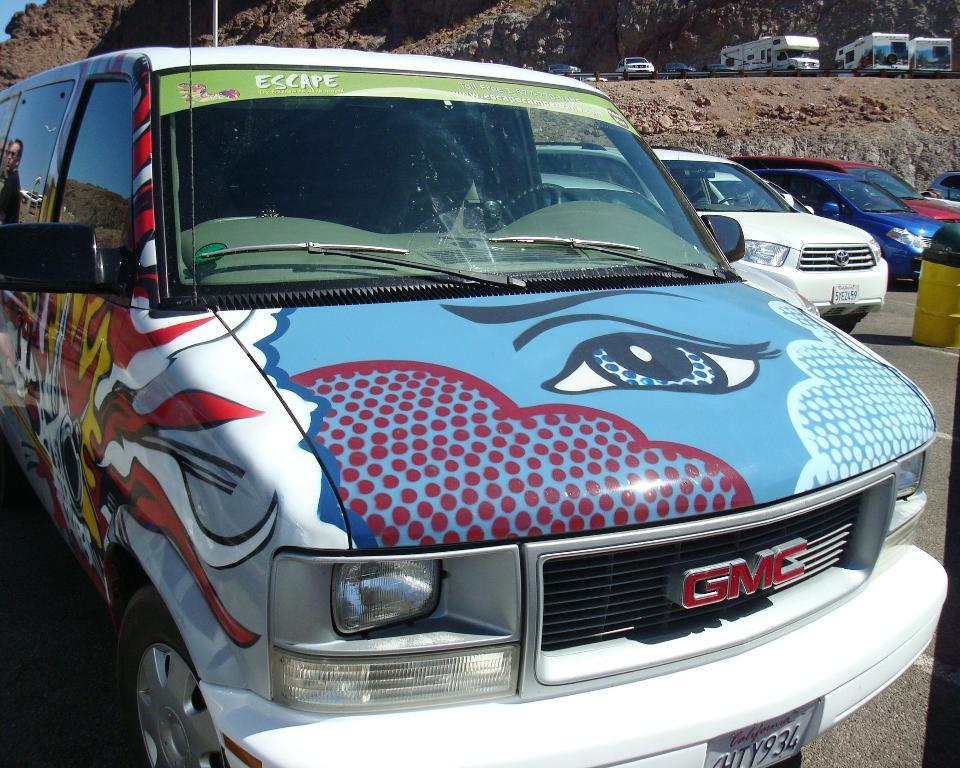<image>
Summarize the visual content of the image. A GMC van with colorful graphics and a California license plate. 